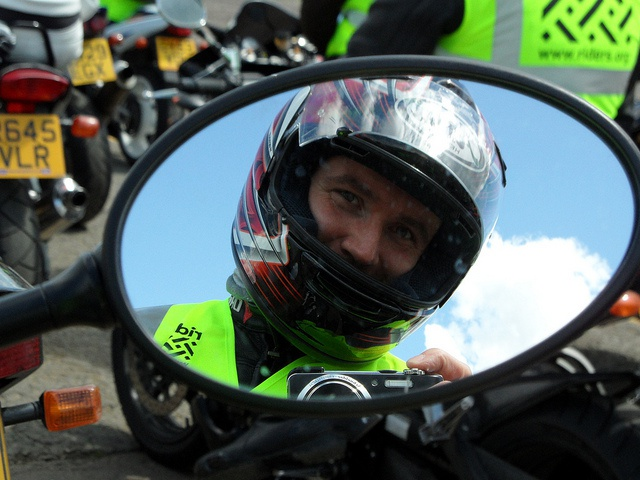Describe the objects in this image and their specific colors. I can see motorcycle in black, lightblue, white, and gray tones, people in lightblue, black, white, gray, and darkgray tones, motorcycle in lightblue, black, maroon, gray, and olive tones, motorcycle in lightblue, black, gray, and darkgray tones, and motorcycle in darkgray, black, and gray tones in this image. 